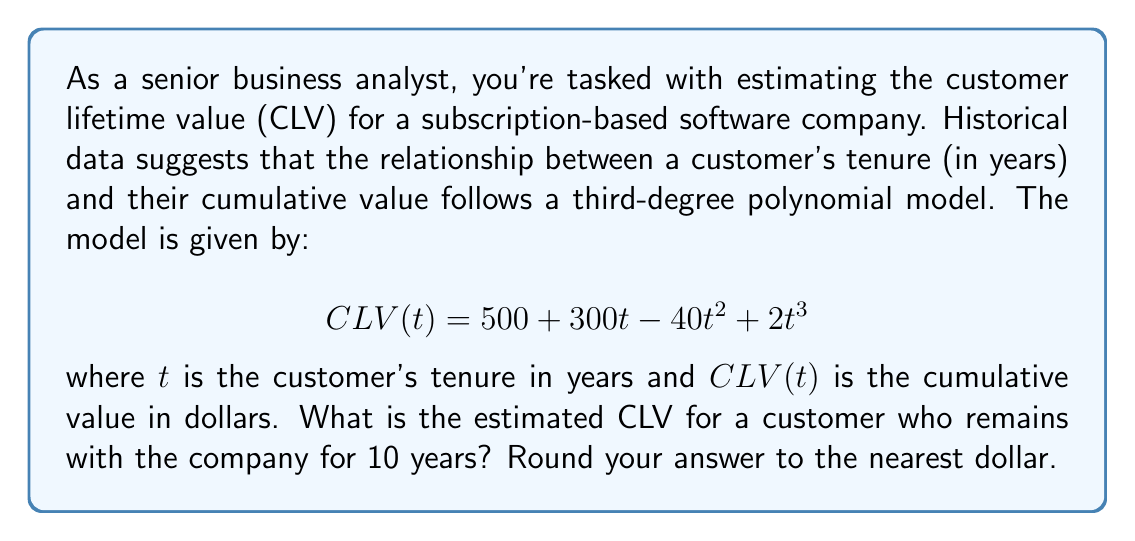Help me with this question. To solve this problem, we need to follow these steps:

1. Identify the given polynomial function:
   $$ CLV(t) = 500 + 300t - 40t^2 + 2t^3 $$

2. Substitute $t = 10$ into the function:
   $$ CLV(10) = 500 + 300(10) - 40(10^2) + 2(10^3) $$

3. Evaluate each term:
   - Constant term: $500$
   - Linear term: $300(10) = 3000$
   - Quadratic term: $-40(10^2) = -40(100) = -4000$
   - Cubic term: $2(10^3) = 2(1000) = 2000$

4. Sum up all the terms:
   $$ CLV(10) = 500 + 3000 - 4000 + 2000 = 1500 $$

5. Round to the nearest dollar (in this case, no rounding is necessary).

Therefore, the estimated Customer Lifetime Value for a customer who remains with the company for 10 years is $1,500.

This higher-degree polynomial model captures the non-linear relationship between customer tenure and value, which is often more realistic than simpler linear models. It accounts for initial acquisition costs (intercept), growth in value over time (positive linear and cubic terms), and potential saturation effects (negative quadratic term).
Answer: $1,500 